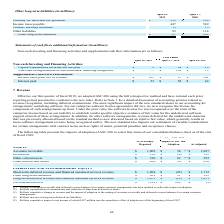From Netapp's financial document, Which years does the table provide information for non-cash investing and financing activities and supplemental cash flow information for? The document contains multiple relevant values: 2019, 2018, 2017. From the document: "April 26, 2019 April 27, 2018 April 28, 2017 April 26, 2019 April 27, 2018 April 28, 2017 April 26, 2019 April 27, 2018 April 28, 2017..." Also, What was the capital expenditures incurred but not paid in 2019? According to the financial document, 9 (in millions). The relevant text states: "April 26, 2019 April 27, 2018 April 28, 2017..." Also, What was the non-cash extinguishment of sale-leaseback financing in 2017? According to the financial document, 19 (in millions). The relevant text states: "April 26, 2019 April 27, 2018 April 28, 2017..." Also, How many years did interest paid exceed $50 million? Counting the relevant items in the document: 2019, 2018, I find 2 instances. The key data points involved are: 2018, 2019. Also, can you calculate: What was the change in capital expenditures incurred but not paid between 2017 and 2018? Based on the calculation: 24-19, the result is 5 (in millions). This is based on the information: "tal expenditures incurred but not paid $ 9 $ 24 $ 19 Capital expenditures incurred but not paid $ 9 $ 24 $ 19..." The key data points involved are: 19, 24. Also, can you calculate: What was the percentage change in income taxes paid, net of refunds between 2018 and 2019? To answer this question, I need to perform calculations using the financial data. The calculation is: (205-87)/87, which equals 135.63 (percentage). This is based on the information: "Income taxes paid, net of refunds $ 205 $ 87 $ 102 Income taxes paid, net of refunds $ 205 $ 87 $ 102..." The key data points involved are: 205, 87. 